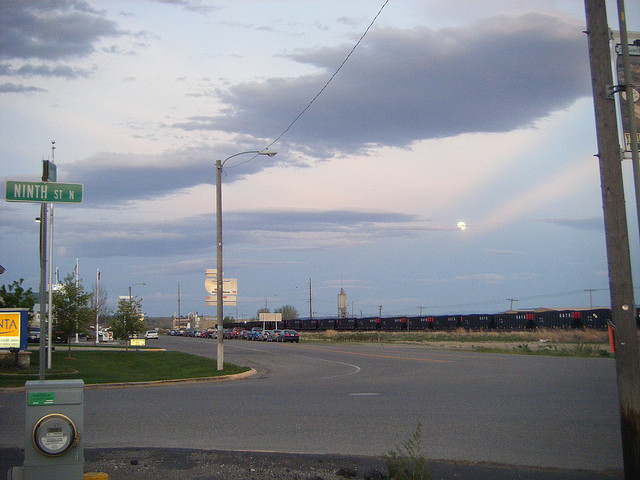Identify the text contained in this image. NINTH ST H NTA 